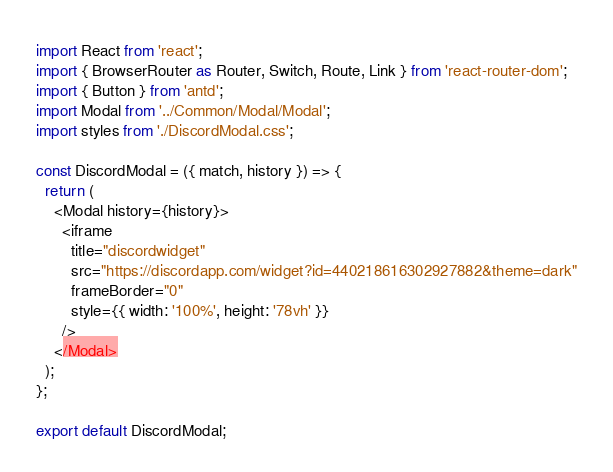<code> <loc_0><loc_0><loc_500><loc_500><_JavaScript_>import React from 'react';
import { BrowserRouter as Router, Switch, Route, Link } from 'react-router-dom';
import { Button } from 'antd';
import Modal from '../Common/Modal/Modal';
import styles from './DiscordModal.css';

const DiscordModal = ({ match, history }) => {
  return (
    <Modal history={history}>
      <iframe
        title="discordwidget"
        src="https://discordapp.com/widget?id=440218616302927882&theme=dark"
        frameBorder="0"
        style={{ width: '100%', height: '78vh' }}
      />
    </Modal>
  );
};

export default DiscordModal;
</code> 